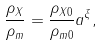<formula> <loc_0><loc_0><loc_500><loc_500>\frac { \rho _ { X } } { \rho _ { m } } = \frac { \rho _ { X 0 } } { \rho _ { m 0 } } a ^ { \xi } ,</formula> 